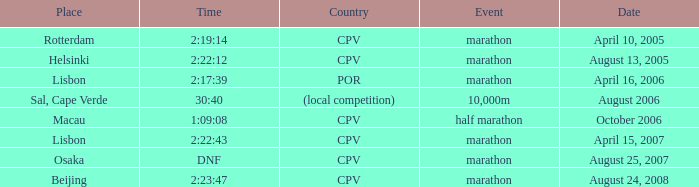What is the Place of the Event on August 25, 2007? Osaka. 